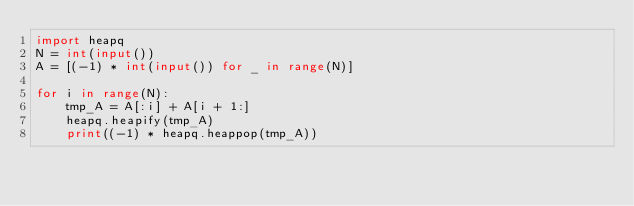Convert code to text. <code><loc_0><loc_0><loc_500><loc_500><_Python_>import heapq
N = int(input())
A = [(-1) * int(input()) for _ in range(N)]

for i in range(N):
    tmp_A = A[:i] + A[i + 1:]
    heapq.heapify(tmp_A)
    print((-1) * heapq.heappop(tmp_A))</code> 